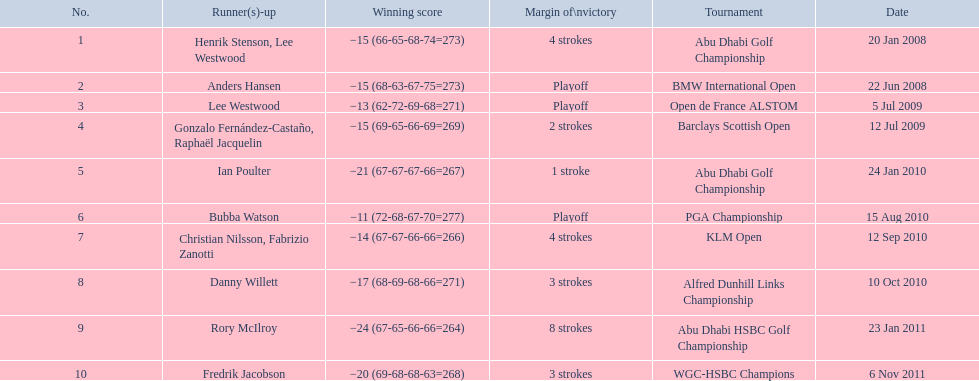What were all the different tournaments played by martin kaymer Abu Dhabi Golf Championship, BMW International Open, Open de France ALSTOM, Barclays Scottish Open, Abu Dhabi Golf Championship, PGA Championship, KLM Open, Alfred Dunhill Links Championship, Abu Dhabi HSBC Golf Championship, WGC-HSBC Champions. Who was the runner-up for the pga championship? Bubba Watson. 